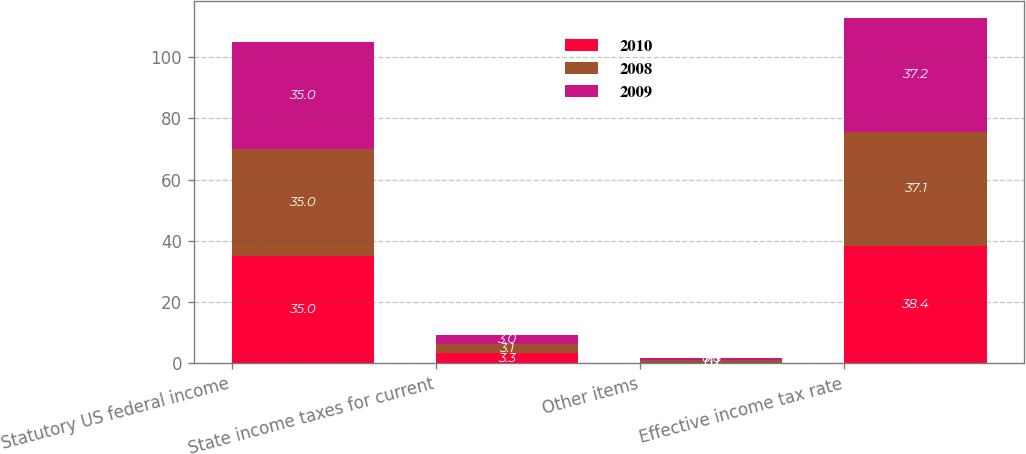Convert chart. <chart><loc_0><loc_0><loc_500><loc_500><stacked_bar_chart><ecel><fcel>Statutory US federal income<fcel>State income taxes for current<fcel>Other items<fcel>Effective income tax rate<nl><fcel>2010<fcel>35<fcel>3.3<fcel>0.1<fcel>38.4<nl><fcel>2008<fcel>35<fcel>3.1<fcel>1<fcel>37.1<nl><fcel>2009<fcel>35<fcel>3<fcel>0.8<fcel>37.2<nl></chart> 